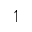Convert formula to latex. <formula><loc_0><loc_0><loc_500><loc_500>\upharpoonleft</formula> 